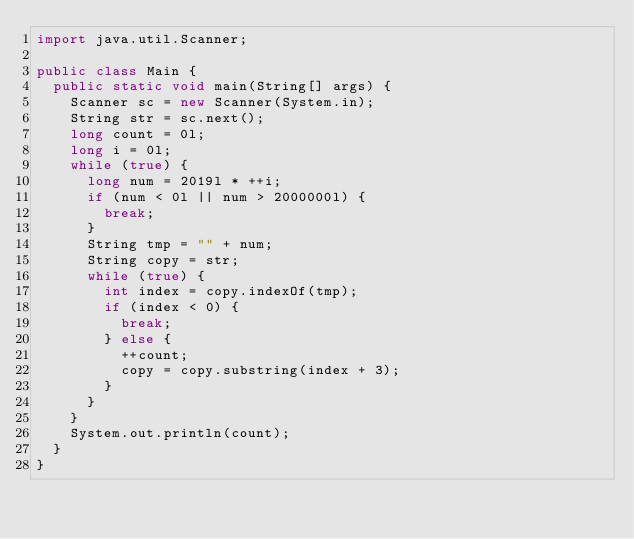<code> <loc_0><loc_0><loc_500><loc_500><_Java_>import java.util.Scanner;

public class Main {
	public static void main(String[] args) {
		Scanner sc = new Scanner(System.in);
		String str = sc.next();
		long count = 0l;
		long i = 0l;
		while (true) {
			long num = 2019l * ++i;
			if (num < 0l || num > 2000000l) {
				break;
			}
			String tmp = "" + num;
			String copy = str;
			while (true) {
				int index = copy.indexOf(tmp);
				if (index < 0) {
					break;
				} else {
					++count;
					copy = copy.substring(index + 3);
				}
			}
		}
		System.out.println(count);
	}
}
</code> 